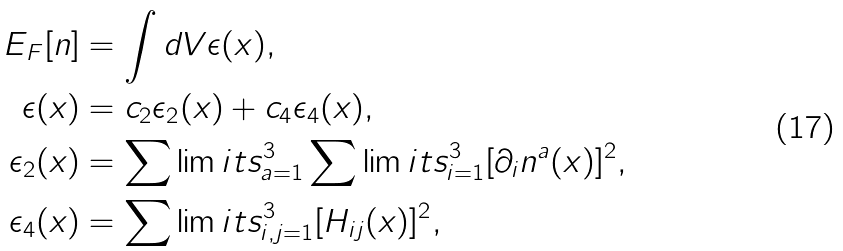Convert formula to latex. <formula><loc_0><loc_0><loc_500><loc_500>E _ { F } [ n ] & = \int d V \epsilon ( x ) , \\ \epsilon ( x ) & = c _ { 2 } \epsilon _ { 2 } ( x ) + c _ { 4 } \epsilon _ { 4 } ( x ) , \\ \epsilon _ { 2 } ( x ) & = \sum \lim i t s _ { a = 1 } ^ { 3 } \sum \lim i t s _ { i = 1 } ^ { 3 } [ \partial _ { i } n ^ { a } ( x ) ] ^ { 2 } , \\ \epsilon _ { 4 } ( x ) & = \sum \lim i t s _ { i , j = 1 } ^ { 3 } [ H _ { i j } ( x ) ] ^ { 2 } ,</formula> 